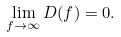Convert formula to latex. <formula><loc_0><loc_0><loc_500><loc_500>\lim _ { f \to \infty } D ( f ) = 0 .</formula> 